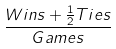<formula> <loc_0><loc_0><loc_500><loc_500>\frac { W i n s + \frac { 1 } { 2 } T i e s } { G a m e s }</formula> 